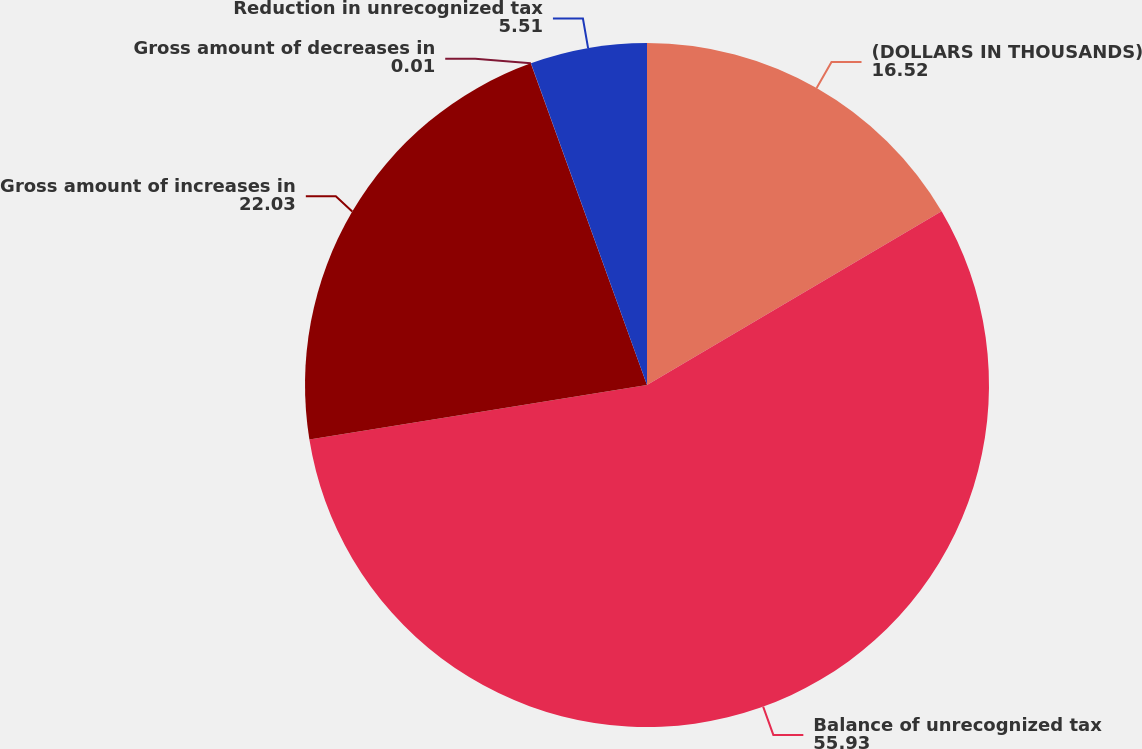<chart> <loc_0><loc_0><loc_500><loc_500><pie_chart><fcel>(DOLLARS IN THOUSANDS)<fcel>Balance of unrecognized tax<fcel>Gross amount of increases in<fcel>Gross amount of decreases in<fcel>Reduction in unrecognized tax<nl><fcel>16.52%<fcel>55.93%<fcel>22.03%<fcel>0.01%<fcel>5.51%<nl></chart> 